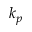<formula> <loc_0><loc_0><loc_500><loc_500>k _ { p }</formula> 